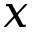<formula> <loc_0><loc_0><loc_500><loc_500>x</formula> 